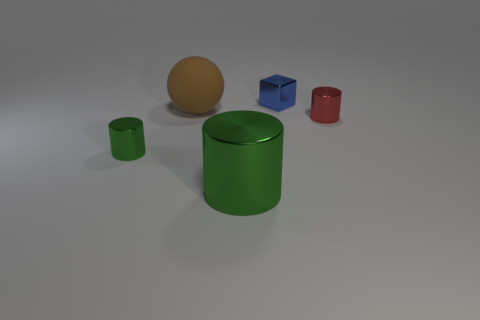There is a large object behind the small green metallic cylinder; what material is it? The object behind the smaller green cylinder is a large brown sphere with a matte finish, which suggests it could be made of a non-metallic material, akin to rubber. 